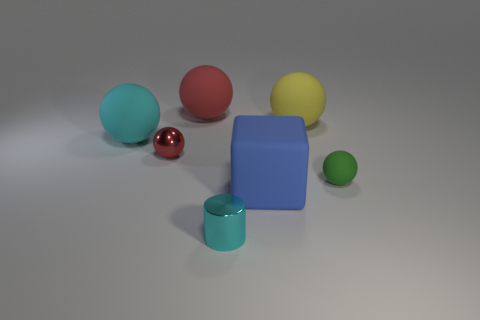What size is the red rubber object?
Offer a terse response. Large. Is there a yellow object that is behind the red thing right of the metal object on the left side of the big red thing?
Your answer should be compact. No. What number of small red metal objects are on the left side of the small red metal sphere?
Offer a terse response. 0. How many other spheres have the same color as the metallic ball?
Offer a terse response. 1. How many things are large matte things that are behind the blue rubber cube or balls that are to the right of the yellow object?
Provide a short and direct response. 4. Is the number of green objects greater than the number of matte objects?
Your answer should be very brief. No. There is a tiny ball to the right of the blue matte cube; what is its color?
Give a very brief answer. Green. Do the green rubber thing and the small red object have the same shape?
Your answer should be compact. Yes. What color is the object that is both in front of the tiny green sphere and on the right side of the small cyan cylinder?
Provide a short and direct response. Blue. There is a green ball that is on the right side of the big yellow matte sphere; is it the same size as the cyan object behind the big rubber block?
Offer a very short reply. No. 